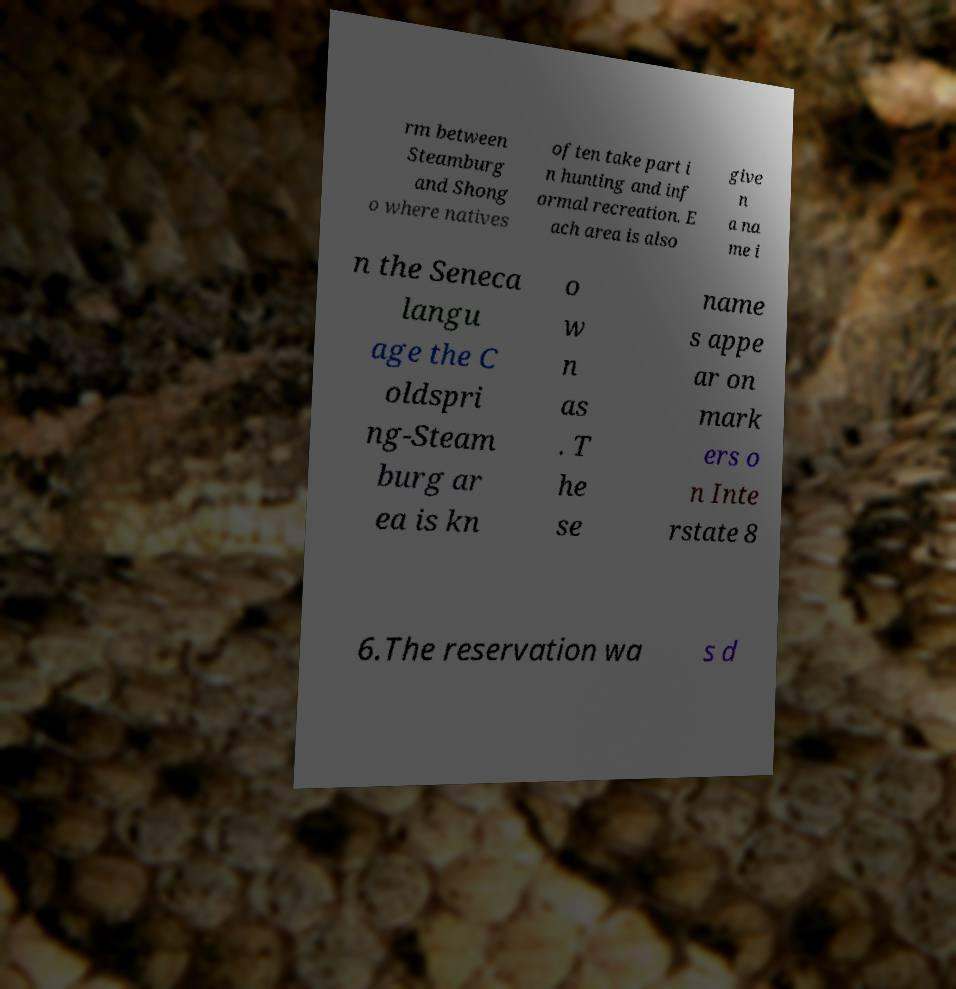There's text embedded in this image that I need extracted. Can you transcribe it verbatim? rm between Steamburg and Shong o where natives often take part i n hunting and inf ormal recreation. E ach area is also give n a na me i n the Seneca langu age the C oldspri ng-Steam burg ar ea is kn o w n as . T he se name s appe ar on mark ers o n Inte rstate 8 6.The reservation wa s d 